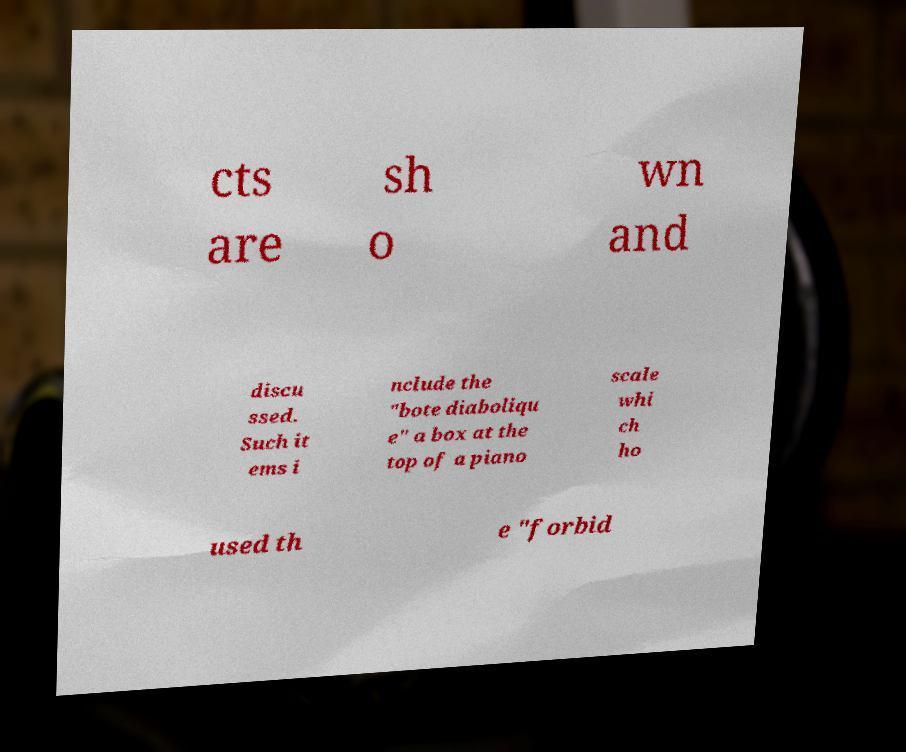Please read and relay the text visible in this image. What does it say? cts are sh o wn and discu ssed. Such it ems i nclude the "bote diaboliqu e" a box at the top of a piano scale whi ch ho used th e "forbid 